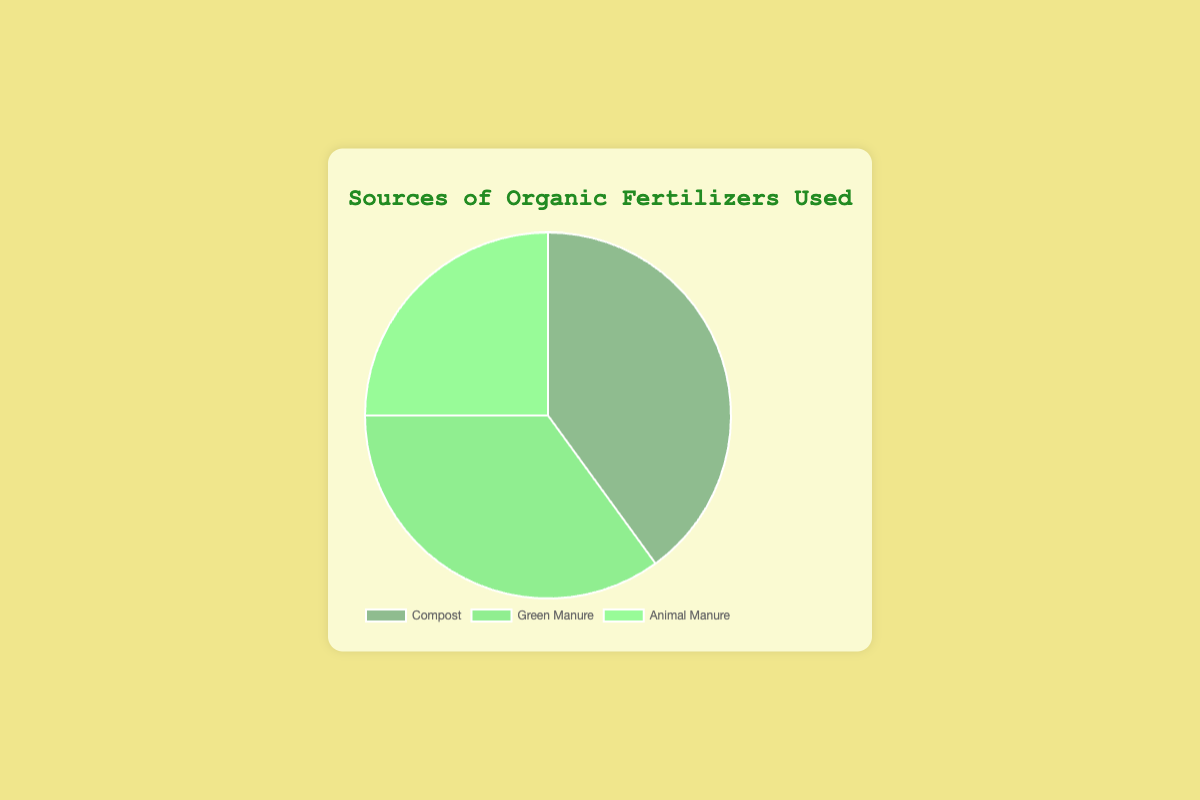What percentage of fertilizer comes from Compost? Compost accounts for 40% of the sources of organic fertilizers, as indicated by the figure.
Answer: 40% Which source of organic fertilizer is used the least? The figure indicates that Animal Manure is used the least, with a percentage of 25%.
Answer: Animal Manure What is the combined percentage of Green Manure and Animal Manure? To find the combined percentage, we add the percentages of Green Manure (35%) and Animal Manure (25%): 35% + 25% = 60%.
Answer: 60% Which source of organic fertilizer has a higher percentage, Compost or Green Manure? By comparing the percentages, Compost has 40% while Green Manure has 35%, so Compost has a higher percentage.
Answer: Compost How much higher is the percentage of Compost compared to Animal Manure? To find how much higher the percentage of Compost is compared to Animal Manure, we subtract the percentage of Animal Manure from Compost: 40% - 25% = 15%.
Answer: 15% Which source occupies a smaller portion of the pie chart, Green Manure or Animal Manure? By comparing the percentages, Green Manure occupies 35% of the pie chart whereas Animal Manure occupies 25%, so Animal Manure occupies a smaller portion.
Answer: Animal Manure What proportion of the pie chart does Compost cover? Compost covers 40% of the pie chart as shown by the segment representing it.
Answer: 40% If the total proportion of Green Manure and Animal Manure is grouped together, how does it compare to Compost? The total proportion of Green Manure and Animal Manure is 60%, which is greater than the proportion of Compost at 40%.
Answer: Greater Which segment in the pie chart is represented by dark green? The Compost segment is represented by dark green in the pie chart.
Answer: Compost 